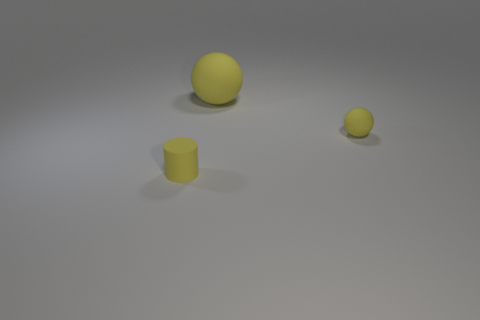Is there anything else that is the same color as the large ball?
Provide a short and direct response. Yes. What number of other things are the same size as the rubber cylinder?
Offer a very short reply. 1. The large ball is what color?
Offer a terse response. Yellow. There is a tiny rubber thing right of the small yellow cylinder; is its color the same as the matte object that is on the left side of the large yellow object?
Your answer should be compact. Yes. The yellow matte cylinder has what size?
Provide a succinct answer. Small. What size is the yellow rubber object in front of the tiny rubber ball?
Make the answer very short. Small. The rubber object that is on the left side of the tiny yellow rubber ball and behind the small rubber cylinder has what shape?
Offer a very short reply. Sphere. What number of other objects are the same shape as the big rubber thing?
Offer a terse response. 1. What is the color of the rubber object that is the same size as the yellow rubber cylinder?
Your response must be concise. Yellow. What number of things are small yellow matte balls or large purple rubber cylinders?
Offer a very short reply. 1. 